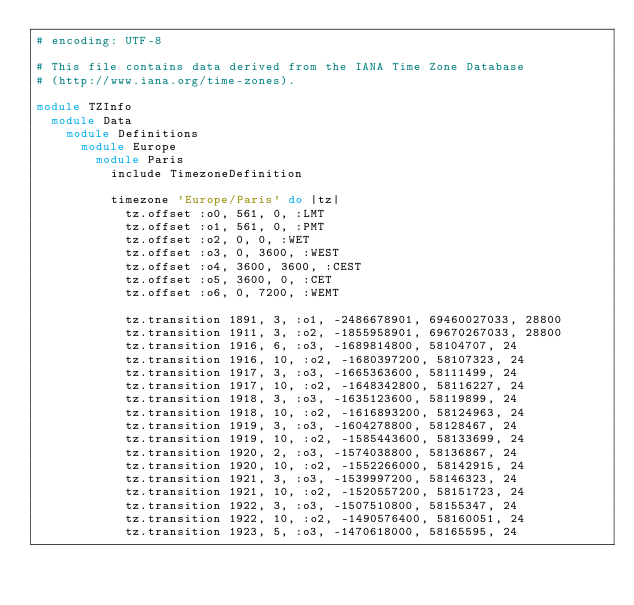<code> <loc_0><loc_0><loc_500><loc_500><_Ruby_># encoding: UTF-8

# This file contains data derived from the IANA Time Zone Database
# (http://www.iana.org/time-zones).

module TZInfo
  module Data
    module Definitions
      module Europe
        module Paris
          include TimezoneDefinition
          
          timezone 'Europe/Paris' do |tz|
            tz.offset :o0, 561, 0, :LMT
            tz.offset :o1, 561, 0, :PMT
            tz.offset :o2, 0, 0, :WET
            tz.offset :o3, 0, 3600, :WEST
            tz.offset :o4, 3600, 3600, :CEST
            tz.offset :o5, 3600, 0, :CET
            tz.offset :o6, 0, 7200, :WEMT
            
            tz.transition 1891, 3, :o1, -2486678901, 69460027033, 28800
            tz.transition 1911, 3, :o2, -1855958901, 69670267033, 28800
            tz.transition 1916, 6, :o3, -1689814800, 58104707, 24
            tz.transition 1916, 10, :o2, -1680397200, 58107323, 24
            tz.transition 1917, 3, :o3, -1665363600, 58111499, 24
            tz.transition 1917, 10, :o2, -1648342800, 58116227, 24
            tz.transition 1918, 3, :o3, -1635123600, 58119899, 24
            tz.transition 1918, 10, :o2, -1616893200, 58124963, 24
            tz.transition 1919, 3, :o3, -1604278800, 58128467, 24
            tz.transition 1919, 10, :o2, -1585443600, 58133699, 24
            tz.transition 1920, 2, :o3, -1574038800, 58136867, 24
            tz.transition 1920, 10, :o2, -1552266000, 58142915, 24
            tz.transition 1921, 3, :o3, -1539997200, 58146323, 24
            tz.transition 1921, 10, :o2, -1520557200, 58151723, 24
            tz.transition 1922, 3, :o3, -1507510800, 58155347, 24
            tz.transition 1922, 10, :o2, -1490576400, 58160051, 24
            tz.transition 1923, 5, :o3, -1470618000, 58165595, 24</code> 